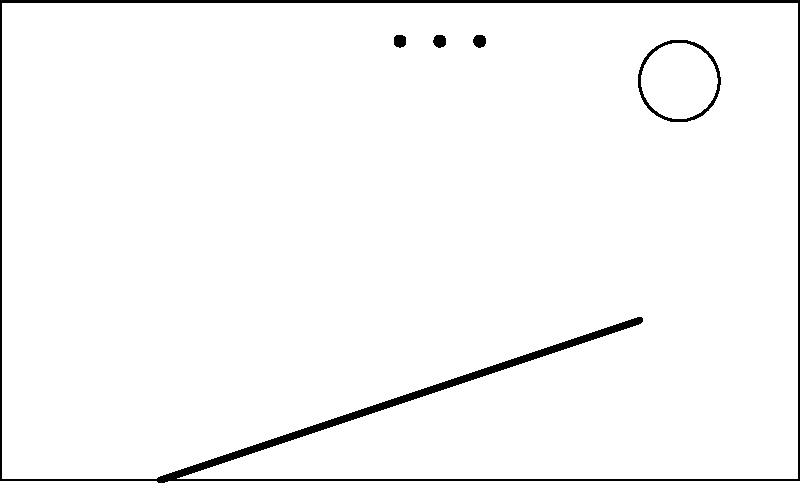In designing a public transportation shelter with universal access features, which of the following elements is most critical for ensuring accessibility for individuals with mobility impairments?
A) Braille signage
B) Audio information system
C) Ramp with appropriate slope
D) Wide entrance To answer this question, let's consider the needs of individuals with mobility impairments and analyze each option:

1. Braille signage:
   - While important for visually impaired users, it doesn't directly address mobility issues.

2. Audio information system:
   - Helpful for various users, including those with visual impairments, but not specifically for mobility challenges.

3. Ramp with appropriate slope:
   - Crucial for wheelchair users and those with difficulty climbing stairs.
   - Allows independent access to the shelter.
   - The slope is important: ADA guidelines recommend a maximum slope of 1:12 (rise:run).

4. Wide entrance:
   - Important for wheelchair users and those with mobility aids.
   - Typically, a minimum width of 32 inches (81.3 cm) is required.

While all these features contribute to universal access, the ramp is the most critical element for individuals with mobility impairments. Without a ramp, many users might not be able to enter the shelter at all, regardless of other accessibility features inside.

The ramp provides:
1. Independent access for wheelchair users
2. Easier access for those using walkers, canes, or other mobility aids
3. A gentler entrance option for elderly individuals or those with temporary injuries

Therefore, the ramp with an appropriate slope is the most critical element for ensuring accessibility for individuals with mobility impairments in this public transportation shelter design.
Answer: C) Ramp with appropriate slope 